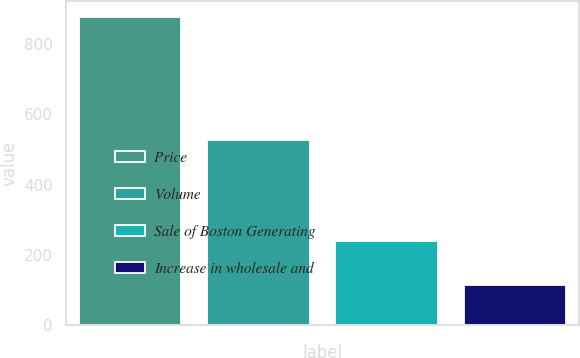Convert chart. <chart><loc_0><loc_0><loc_500><loc_500><bar_chart><fcel>Price<fcel>Volume<fcel>Sale of Boston Generating<fcel>Increase in wholesale and<nl><fcel>879<fcel>526<fcel>239<fcel>114<nl></chart> 